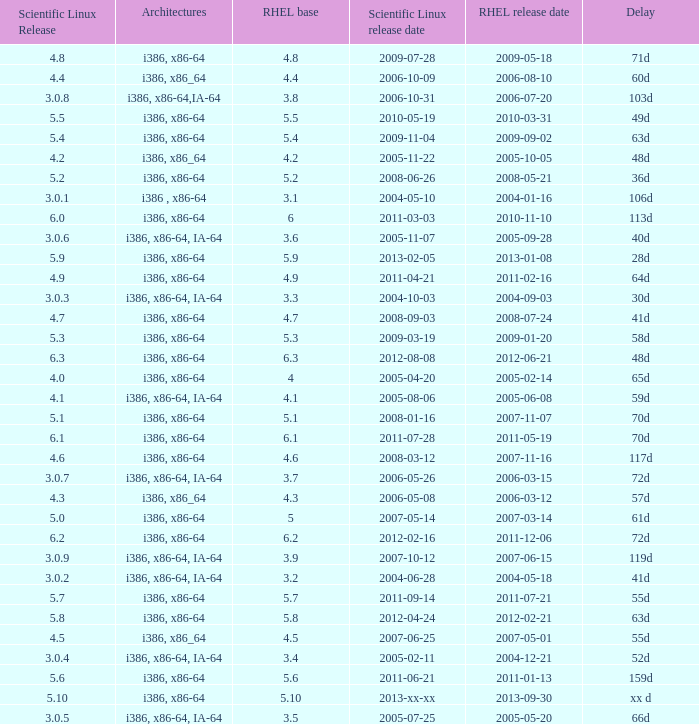When is the rhel release date when scientific linux release is 3.0.4 2004-12-21. 